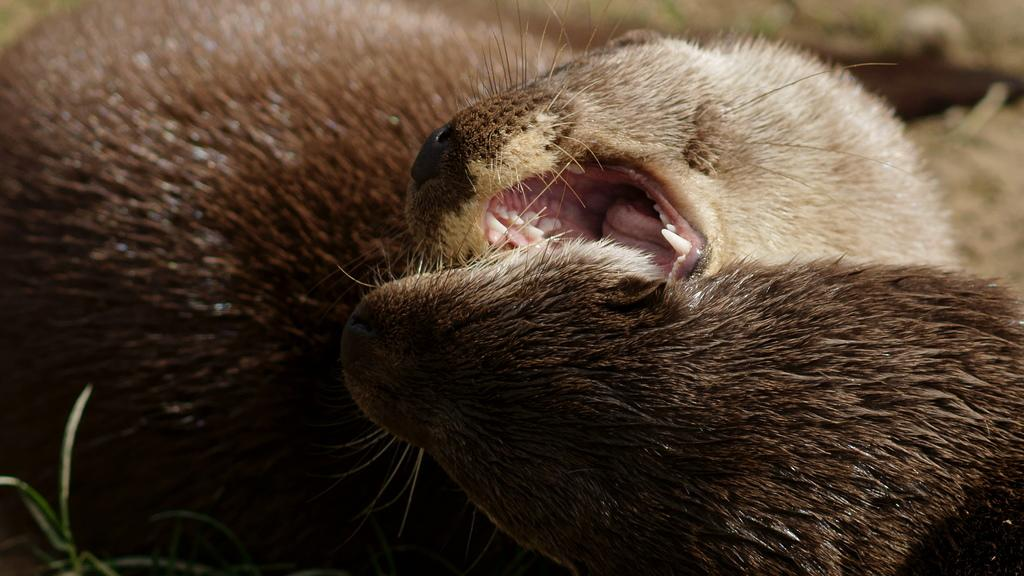How many animals are present in the image? There are two animals in the image. Can you describe the background of the image? The background of the image is blurred. What type of gate can be seen in the image? There is no gate present in the image; it only features two animals and a blurred background. 